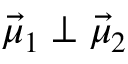Convert formula to latex. <formula><loc_0><loc_0><loc_500><loc_500>\ V e c { \mu } _ { 1 } \perp \ V e c { \mu } _ { 2 }</formula> 